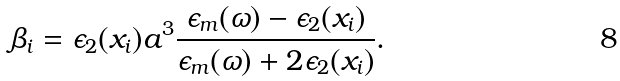Convert formula to latex. <formula><loc_0><loc_0><loc_500><loc_500>\beta _ { i } = \epsilon _ { 2 } ( x _ { i } ) a ^ { 3 } \frac { \epsilon _ { m } ( \omega ) - \epsilon _ { 2 } ( x _ { i } ) } { \epsilon _ { m } ( \omega ) + 2 \epsilon _ { 2 } ( x _ { i } ) } .</formula> 